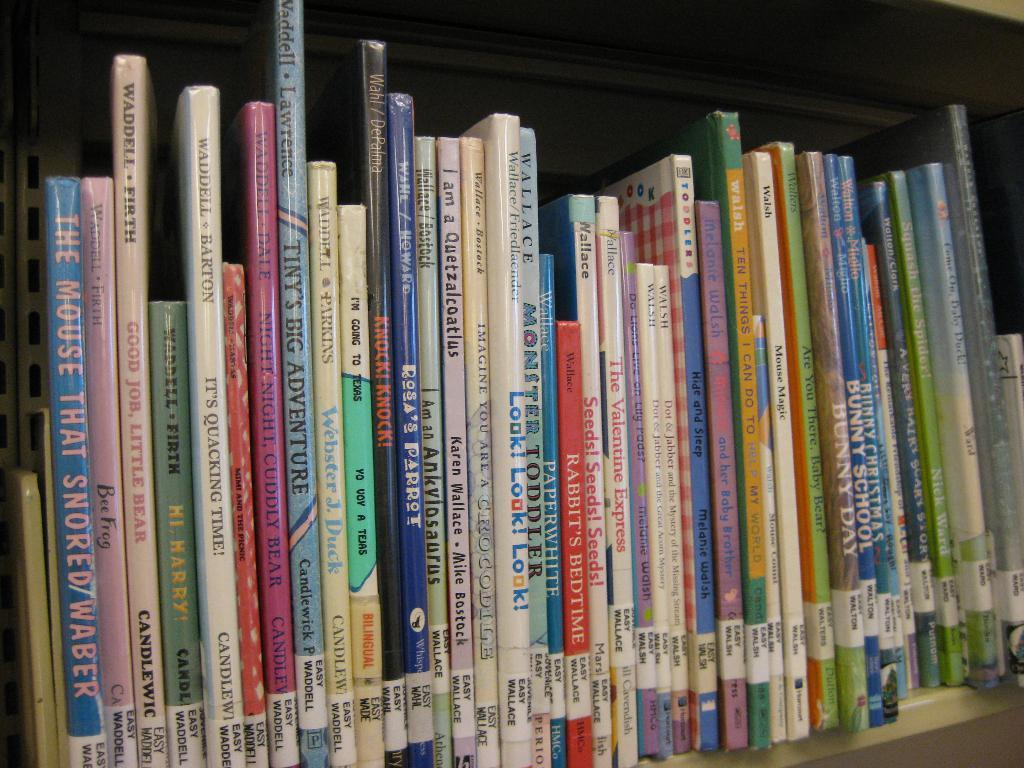<image>
Create a compact narrative representing the image presented. A bookshelf of children's books with the book The Mouse That Snored. 